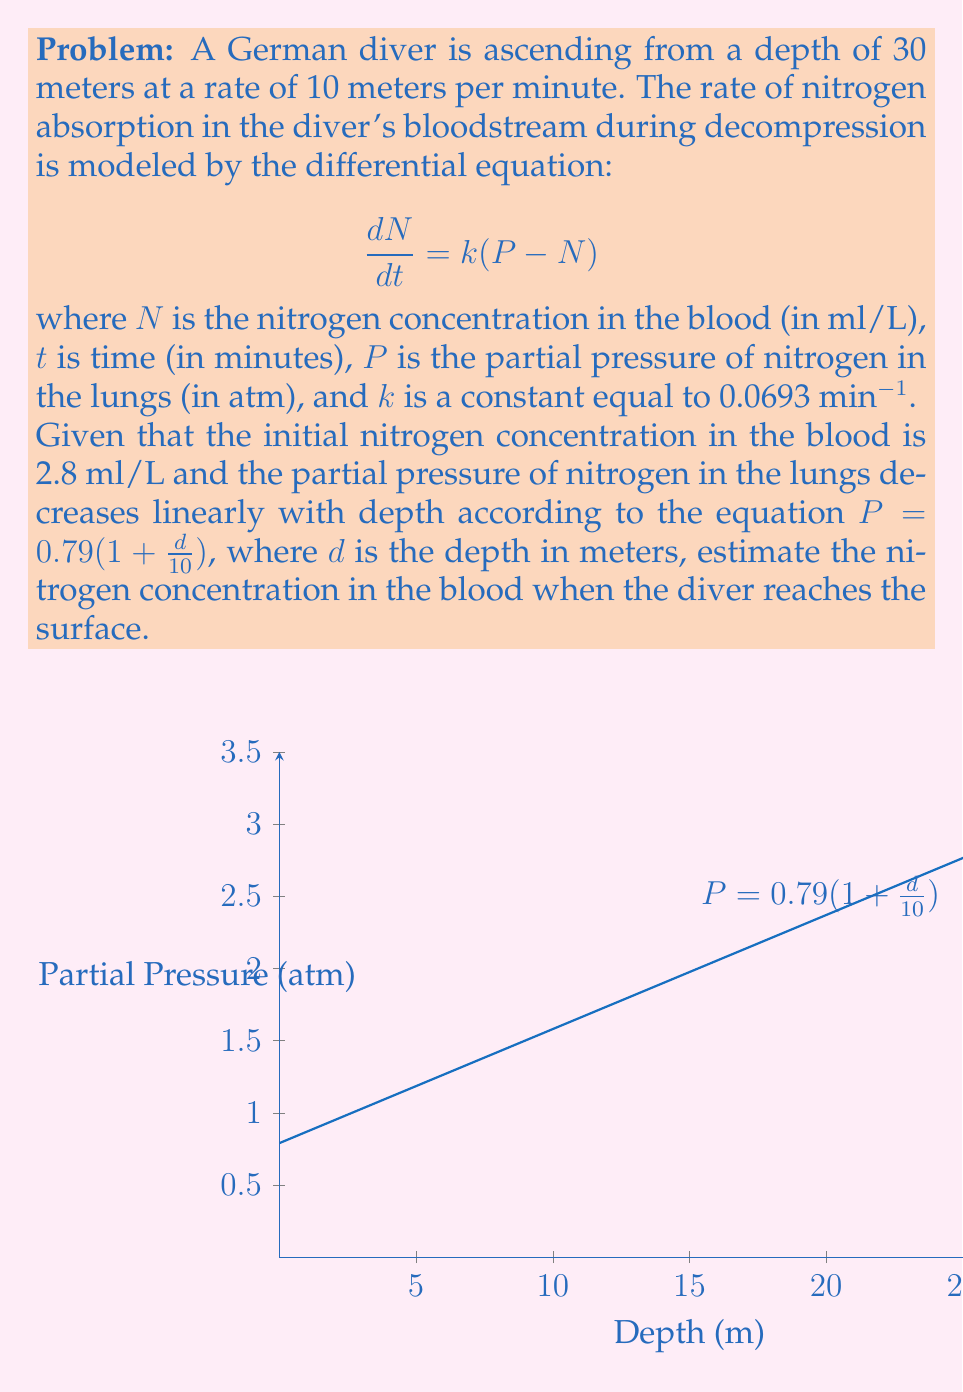Show me your answer to this math problem. Let's approach this problem step-by-step:

1) First, we need to determine how long it takes the diver to reach the surface:
   Time = Distance / Rate = 30 m / (10 m/min) = 3 minutes

2) Next, we need to find the partial pressure of nitrogen at the surface:
   $P_{surface} = 0.79(1 + \frac{0}{10}) = 0.79$ atm

3) The differential equation given is a first-order linear differential equation. Its solution is:
   $$N(t) = P + (N_0 - P)e^{-kt}$$
   where $N_0$ is the initial nitrogen concentration.

4) We know:
   $N_0 = 2.8$ ml/L
   $k = 0.0693$ min⁻¹
   $t = 3$ minutes
   $P_{surface} = 0.79$ atm

5) Substituting these values into the solution:
   $$N(3) = 0.79 + (2.8 - 0.79)e^{-0.0693 \cdot 3}$$

6) Calculating:
   $$N(3) = 0.79 + 2.01e^{-0.2079}$$
   $$N(3) = 0.79 + 2.01 \cdot 0.8123$$
   $$N(3) = 0.79 + 1.6327$$
   $$N(3) = 2.4227$$ ml/L

Therefore, when the diver reaches the surface, the estimated nitrogen concentration in the blood is approximately 2.42 ml/L.
Answer: 2.42 ml/L 